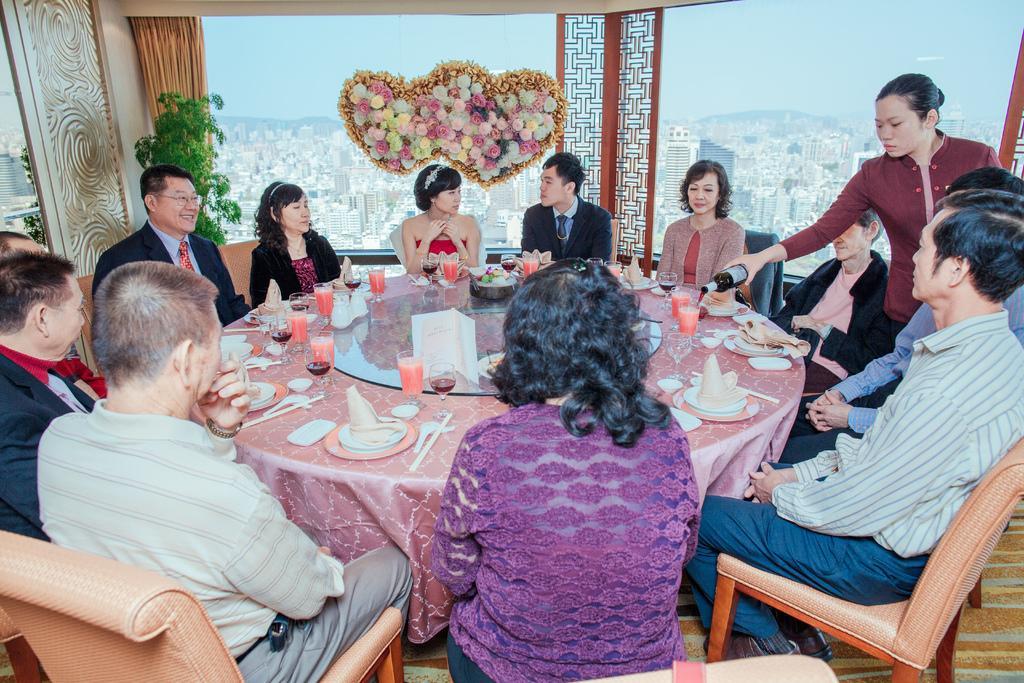Can you describe this image briefly? In this image I can see people where a woman is standing and holding a bottle and rest all are sitting on chairs. On this table I can see glasses, plates and spoons. In the background I can see decorations and a plant. 